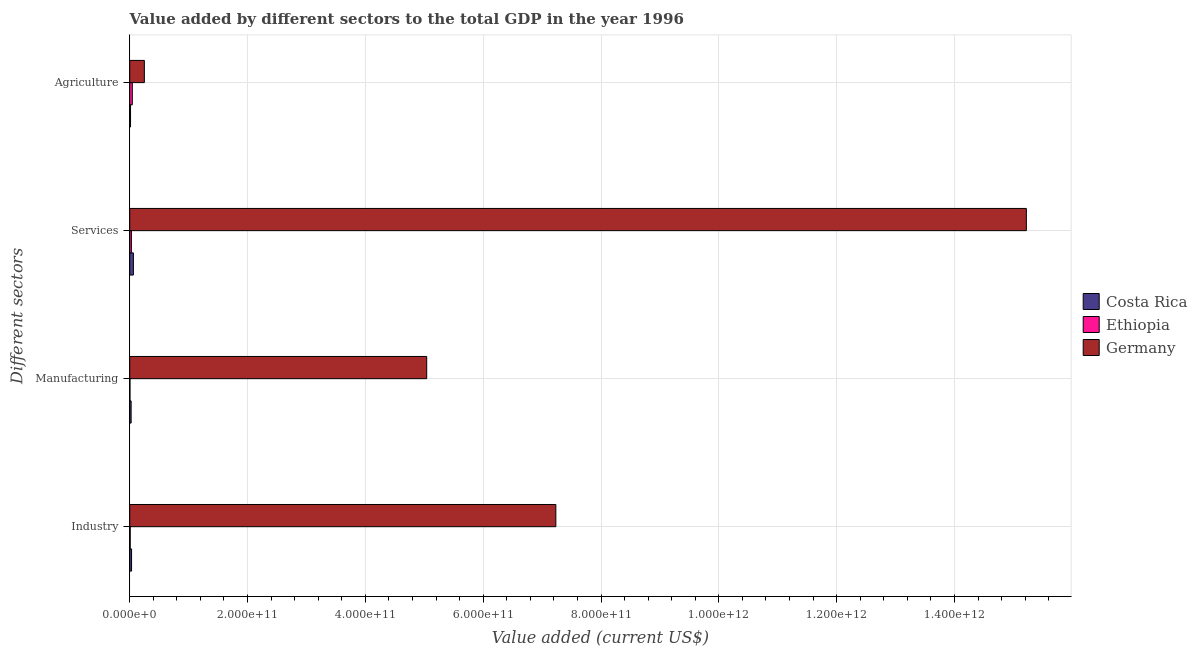How many groups of bars are there?
Your answer should be very brief. 4. Are the number of bars on each tick of the Y-axis equal?
Give a very brief answer. Yes. How many bars are there on the 1st tick from the top?
Keep it short and to the point. 3. What is the label of the 1st group of bars from the top?
Your response must be concise. Agriculture. What is the value added by services sector in Costa Rica?
Provide a short and direct response. 6.26e+09. Across all countries, what is the maximum value added by agricultural sector?
Your response must be concise. 2.48e+1. Across all countries, what is the minimum value added by manufacturing sector?
Offer a very short reply. 4.46e+08. In which country was the value added by services sector minimum?
Your response must be concise. Ethiopia. What is the total value added by manufacturing sector in the graph?
Make the answer very short. 5.07e+11. What is the difference between the value added by industrial sector in Germany and that in Costa Rica?
Your answer should be very brief. 7.20e+11. What is the difference between the value added by services sector in Ethiopia and the value added by industrial sector in Germany?
Ensure brevity in your answer.  -7.20e+11. What is the average value added by manufacturing sector per country?
Ensure brevity in your answer.  1.69e+11. What is the difference between the value added by agricultural sector and value added by services sector in Costa Rica?
Ensure brevity in your answer.  -4.87e+09. In how many countries, is the value added by industrial sector greater than 760000000000 US$?
Provide a succinct answer. 0. What is the ratio of the value added by agricultural sector in Ethiopia to that in Germany?
Ensure brevity in your answer.  0.18. Is the value added by agricultural sector in Costa Rica less than that in Ethiopia?
Offer a terse response. Yes. What is the difference between the highest and the second highest value added by agricultural sector?
Provide a succinct answer. 2.05e+1. What is the difference between the highest and the lowest value added by manufacturing sector?
Provide a succinct answer. 5.04e+11. In how many countries, is the value added by services sector greater than the average value added by services sector taken over all countries?
Your response must be concise. 1. What does the 1st bar from the top in Manufacturing represents?
Your response must be concise. Germany. How many bars are there?
Give a very brief answer. 12. What is the difference between two consecutive major ticks on the X-axis?
Ensure brevity in your answer.  2.00e+11. Does the graph contain any zero values?
Keep it short and to the point. No. Where does the legend appear in the graph?
Keep it short and to the point. Center right. How many legend labels are there?
Your answer should be compact. 3. What is the title of the graph?
Provide a succinct answer. Value added by different sectors to the total GDP in the year 1996. Does "Namibia" appear as one of the legend labels in the graph?
Give a very brief answer. No. What is the label or title of the X-axis?
Offer a very short reply. Value added (current US$). What is the label or title of the Y-axis?
Provide a short and direct response. Different sectors. What is the Value added (current US$) in Costa Rica in Industry?
Give a very brief answer. 3.13e+09. What is the Value added (current US$) in Ethiopia in Industry?
Ensure brevity in your answer.  8.36e+08. What is the Value added (current US$) of Germany in Industry?
Give a very brief answer. 7.23e+11. What is the Value added (current US$) of Costa Rica in Manufacturing?
Give a very brief answer. 2.38e+09. What is the Value added (current US$) of Ethiopia in Manufacturing?
Offer a terse response. 4.46e+08. What is the Value added (current US$) of Germany in Manufacturing?
Provide a short and direct response. 5.04e+11. What is the Value added (current US$) in Costa Rica in Services?
Provide a short and direct response. 6.26e+09. What is the Value added (current US$) of Ethiopia in Services?
Ensure brevity in your answer.  2.84e+09. What is the Value added (current US$) of Germany in Services?
Keep it short and to the point. 1.52e+12. What is the Value added (current US$) in Costa Rica in Agriculture?
Your response must be concise. 1.38e+09. What is the Value added (current US$) of Ethiopia in Agriculture?
Provide a short and direct response. 4.37e+09. What is the Value added (current US$) in Germany in Agriculture?
Your response must be concise. 2.48e+1. Across all Different sectors, what is the maximum Value added (current US$) of Costa Rica?
Your answer should be compact. 6.26e+09. Across all Different sectors, what is the maximum Value added (current US$) in Ethiopia?
Provide a succinct answer. 4.37e+09. Across all Different sectors, what is the maximum Value added (current US$) in Germany?
Your response must be concise. 1.52e+12. Across all Different sectors, what is the minimum Value added (current US$) in Costa Rica?
Provide a short and direct response. 1.38e+09. Across all Different sectors, what is the minimum Value added (current US$) of Ethiopia?
Keep it short and to the point. 4.46e+08. Across all Different sectors, what is the minimum Value added (current US$) in Germany?
Provide a short and direct response. 2.48e+1. What is the total Value added (current US$) of Costa Rica in the graph?
Give a very brief answer. 1.31e+1. What is the total Value added (current US$) in Ethiopia in the graph?
Make the answer very short. 8.50e+09. What is the total Value added (current US$) of Germany in the graph?
Your answer should be very brief. 2.77e+12. What is the difference between the Value added (current US$) of Costa Rica in Industry and that in Manufacturing?
Keep it short and to the point. 7.46e+08. What is the difference between the Value added (current US$) in Ethiopia in Industry and that in Manufacturing?
Offer a terse response. 3.91e+08. What is the difference between the Value added (current US$) of Germany in Industry and that in Manufacturing?
Provide a succinct answer. 2.19e+11. What is the difference between the Value added (current US$) of Costa Rica in Industry and that in Services?
Offer a very short reply. -3.13e+09. What is the difference between the Value added (current US$) in Ethiopia in Industry and that in Services?
Your response must be concise. -2.01e+09. What is the difference between the Value added (current US$) of Germany in Industry and that in Services?
Make the answer very short. -7.99e+11. What is the difference between the Value added (current US$) in Costa Rica in Industry and that in Agriculture?
Your response must be concise. 1.74e+09. What is the difference between the Value added (current US$) in Ethiopia in Industry and that in Agriculture?
Keep it short and to the point. -3.54e+09. What is the difference between the Value added (current US$) of Germany in Industry and that in Agriculture?
Give a very brief answer. 6.98e+11. What is the difference between the Value added (current US$) of Costa Rica in Manufacturing and that in Services?
Make the answer very short. -3.88e+09. What is the difference between the Value added (current US$) in Ethiopia in Manufacturing and that in Services?
Give a very brief answer. -2.40e+09. What is the difference between the Value added (current US$) in Germany in Manufacturing and that in Services?
Make the answer very short. -1.02e+12. What is the difference between the Value added (current US$) in Costa Rica in Manufacturing and that in Agriculture?
Offer a terse response. 9.97e+08. What is the difference between the Value added (current US$) in Ethiopia in Manufacturing and that in Agriculture?
Make the answer very short. -3.93e+09. What is the difference between the Value added (current US$) in Germany in Manufacturing and that in Agriculture?
Your answer should be compact. 4.79e+11. What is the difference between the Value added (current US$) of Costa Rica in Services and that in Agriculture?
Offer a terse response. 4.87e+09. What is the difference between the Value added (current US$) of Ethiopia in Services and that in Agriculture?
Offer a very short reply. -1.53e+09. What is the difference between the Value added (current US$) in Germany in Services and that in Agriculture?
Provide a succinct answer. 1.50e+12. What is the difference between the Value added (current US$) in Costa Rica in Industry and the Value added (current US$) in Ethiopia in Manufacturing?
Give a very brief answer. 2.68e+09. What is the difference between the Value added (current US$) in Costa Rica in Industry and the Value added (current US$) in Germany in Manufacturing?
Offer a very short reply. -5.01e+11. What is the difference between the Value added (current US$) in Ethiopia in Industry and the Value added (current US$) in Germany in Manufacturing?
Offer a very short reply. -5.03e+11. What is the difference between the Value added (current US$) of Costa Rica in Industry and the Value added (current US$) of Ethiopia in Services?
Make the answer very short. 2.81e+08. What is the difference between the Value added (current US$) in Costa Rica in Industry and the Value added (current US$) in Germany in Services?
Your answer should be very brief. -1.52e+12. What is the difference between the Value added (current US$) in Ethiopia in Industry and the Value added (current US$) in Germany in Services?
Ensure brevity in your answer.  -1.52e+12. What is the difference between the Value added (current US$) in Costa Rica in Industry and the Value added (current US$) in Ethiopia in Agriculture?
Make the answer very short. -1.25e+09. What is the difference between the Value added (current US$) of Costa Rica in Industry and the Value added (current US$) of Germany in Agriculture?
Offer a terse response. -2.17e+1. What is the difference between the Value added (current US$) in Ethiopia in Industry and the Value added (current US$) in Germany in Agriculture?
Make the answer very short. -2.40e+1. What is the difference between the Value added (current US$) in Costa Rica in Manufacturing and the Value added (current US$) in Ethiopia in Services?
Offer a terse response. -4.65e+08. What is the difference between the Value added (current US$) in Costa Rica in Manufacturing and the Value added (current US$) in Germany in Services?
Your response must be concise. -1.52e+12. What is the difference between the Value added (current US$) in Ethiopia in Manufacturing and the Value added (current US$) in Germany in Services?
Provide a short and direct response. -1.52e+12. What is the difference between the Value added (current US$) of Costa Rica in Manufacturing and the Value added (current US$) of Ethiopia in Agriculture?
Provide a short and direct response. -1.99e+09. What is the difference between the Value added (current US$) of Costa Rica in Manufacturing and the Value added (current US$) of Germany in Agriculture?
Give a very brief answer. -2.25e+1. What is the difference between the Value added (current US$) of Ethiopia in Manufacturing and the Value added (current US$) of Germany in Agriculture?
Make the answer very short. -2.44e+1. What is the difference between the Value added (current US$) of Costa Rica in Services and the Value added (current US$) of Ethiopia in Agriculture?
Make the answer very short. 1.88e+09. What is the difference between the Value added (current US$) of Costa Rica in Services and the Value added (current US$) of Germany in Agriculture?
Your answer should be very brief. -1.86e+1. What is the difference between the Value added (current US$) of Ethiopia in Services and the Value added (current US$) of Germany in Agriculture?
Keep it short and to the point. -2.20e+1. What is the average Value added (current US$) of Costa Rica per Different sectors?
Offer a very short reply. 3.29e+09. What is the average Value added (current US$) of Ethiopia per Different sectors?
Provide a short and direct response. 2.12e+09. What is the average Value added (current US$) in Germany per Different sectors?
Give a very brief answer. 6.94e+11. What is the difference between the Value added (current US$) in Costa Rica and Value added (current US$) in Ethiopia in Industry?
Your answer should be very brief. 2.29e+09. What is the difference between the Value added (current US$) of Costa Rica and Value added (current US$) of Germany in Industry?
Give a very brief answer. -7.20e+11. What is the difference between the Value added (current US$) in Ethiopia and Value added (current US$) in Germany in Industry?
Provide a short and direct response. -7.22e+11. What is the difference between the Value added (current US$) of Costa Rica and Value added (current US$) of Ethiopia in Manufacturing?
Your answer should be compact. 1.93e+09. What is the difference between the Value added (current US$) of Costa Rica and Value added (current US$) of Germany in Manufacturing?
Ensure brevity in your answer.  -5.02e+11. What is the difference between the Value added (current US$) in Ethiopia and Value added (current US$) in Germany in Manufacturing?
Your response must be concise. -5.04e+11. What is the difference between the Value added (current US$) in Costa Rica and Value added (current US$) in Ethiopia in Services?
Offer a terse response. 3.41e+09. What is the difference between the Value added (current US$) of Costa Rica and Value added (current US$) of Germany in Services?
Offer a terse response. -1.52e+12. What is the difference between the Value added (current US$) of Ethiopia and Value added (current US$) of Germany in Services?
Keep it short and to the point. -1.52e+12. What is the difference between the Value added (current US$) in Costa Rica and Value added (current US$) in Ethiopia in Agriculture?
Provide a short and direct response. -2.99e+09. What is the difference between the Value added (current US$) of Costa Rica and Value added (current US$) of Germany in Agriculture?
Provide a succinct answer. -2.35e+1. What is the difference between the Value added (current US$) in Ethiopia and Value added (current US$) in Germany in Agriculture?
Make the answer very short. -2.05e+1. What is the ratio of the Value added (current US$) of Costa Rica in Industry to that in Manufacturing?
Make the answer very short. 1.31. What is the ratio of the Value added (current US$) in Ethiopia in Industry to that in Manufacturing?
Ensure brevity in your answer.  1.88. What is the ratio of the Value added (current US$) of Germany in Industry to that in Manufacturing?
Offer a terse response. 1.43. What is the ratio of the Value added (current US$) of Costa Rica in Industry to that in Services?
Your answer should be very brief. 0.5. What is the ratio of the Value added (current US$) of Ethiopia in Industry to that in Services?
Offer a very short reply. 0.29. What is the ratio of the Value added (current US$) in Germany in Industry to that in Services?
Offer a terse response. 0.48. What is the ratio of the Value added (current US$) in Costa Rica in Industry to that in Agriculture?
Provide a short and direct response. 2.26. What is the ratio of the Value added (current US$) in Ethiopia in Industry to that in Agriculture?
Make the answer very short. 0.19. What is the ratio of the Value added (current US$) of Germany in Industry to that in Agriculture?
Keep it short and to the point. 29.11. What is the ratio of the Value added (current US$) of Costa Rica in Manufacturing to that in Services?
Your answer should be compact. 0.38. What is the ratio of the Value added (current US$) in Ethiopia in Manufacturing to that in Services?
Provide a succinct answer. 0.16. What is the ratio of the Value added (current US$) in Germany in Manufacturing to that in Services?
Offer a terse response. 0.33. What is the ratio of the Value added (current US$) in Costa Rica in Manufacturing to that in Agriculture?
Provide a succinct answer. 1.72. What is the ratio of the Value added (current US$) in Ethiopia in Manufacturing to that in Agriculture?
Your answer should be very brief. 0.1. What is the ratio of the Value added (current US$) in Germany in Manufacturing to that in Agriculture?
Offer a very short reply. 20.29. What is the ratio of the Value added (current US$) of Costa Rica in Services to that in Agriculture?
Ensure brevity in your answer.  4.52. What is the ratio of the Value added (current US$) in Ethiopia in Services to that in Agriculture?
Ensure brevity in your answer.  0.65. What is the ratio of the Value added (current US$) in Germany in Services to that in Agriculture?
Offer a very short reply. 61.25. What is the difference between the highest and the second highest Value added (current US$) in Costa Rica?
Provide a succinct answer. 3.13e+09. What is the difference between the highest and the second highest Value added (current US$) in Ethiopia?
Offer a very short reply. 1.53e+09. What is the difference between the highest and the second highest Value added (current US$) of Germany?
Offer a very short reply. 7.99e+11. What is the difference between the highest and the lowest Value added (current US$) of Costa Rica?
Your answer should be compact. 4.87e+09. What is the difference between the highest and the lowest Value added (current US$) in Ethiopia?
Offer a very short reply. 3.93e+09. What is the difference between the highest and the lowest Value added (current US$) in Germany?
Provide a short and direct response. 1.50e+12. 